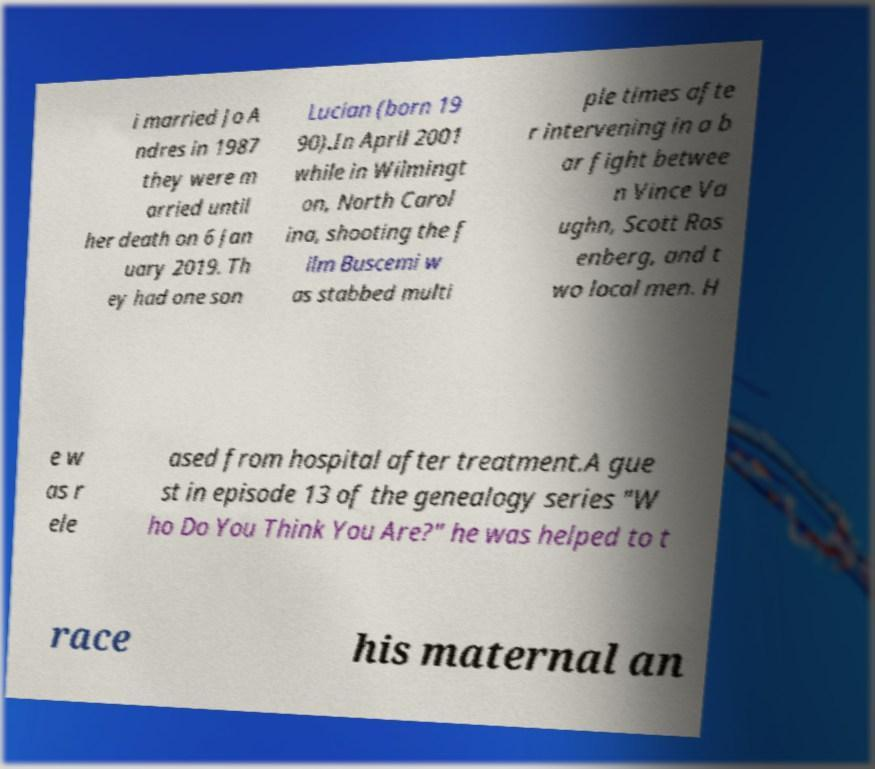For documentation purposes, I need the text within this image transcribed. Could you provide that? i married Jo A ndres in 1987 they were m arried until her death on 6 Jan uary 2019. Th ey had one son Lucian (born 19 90).In April 2001 while in Wilmingt on, North Carol ina, shooting the f ilm Buscemi w as stabbed multi ple times afte r intervening in a b ar fight betwee n Vince Va ughn, Scott Ros enberg, and t wo local men. H e w as r ele ased from hospital after treatment.A gue st in episode 13 of the genealogy series "W ho Do You Think You Are?" he was helped to t race his maternal an 